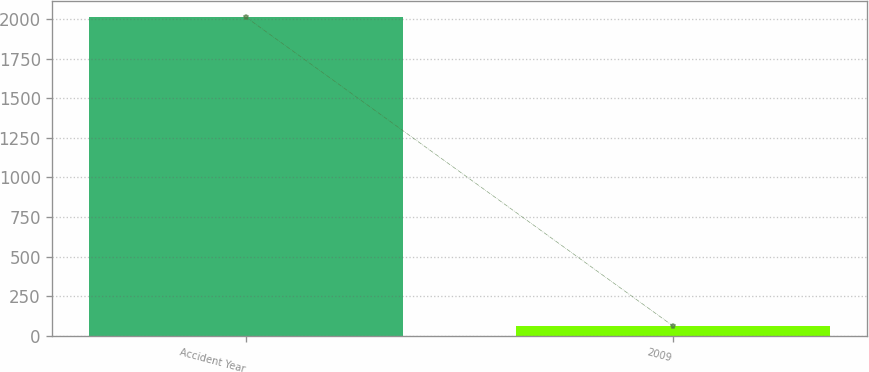Convert chart to OTSL. <chart><loc_0><loc_0><loc_500><loc_500><bar_chart><fcel>Accident Year<fcel>2009<nl><fcel>2010<fcel>63<nl></chart> 